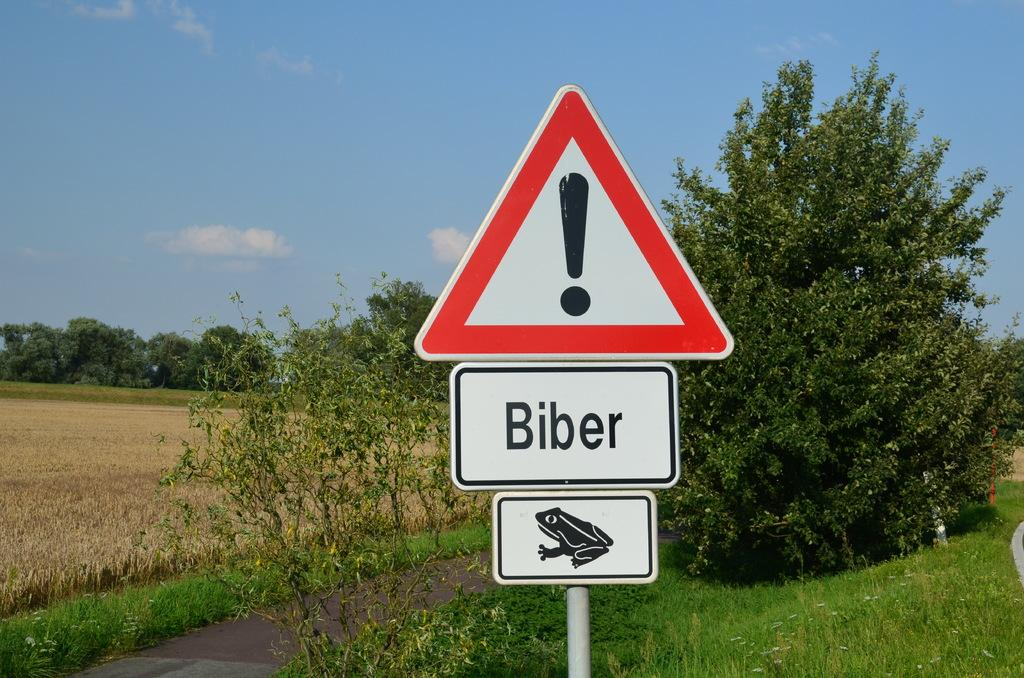<image>
Summarize the visual content of the image. A triangular caution sign with the word Biber on it and a picture of a frog onit. 